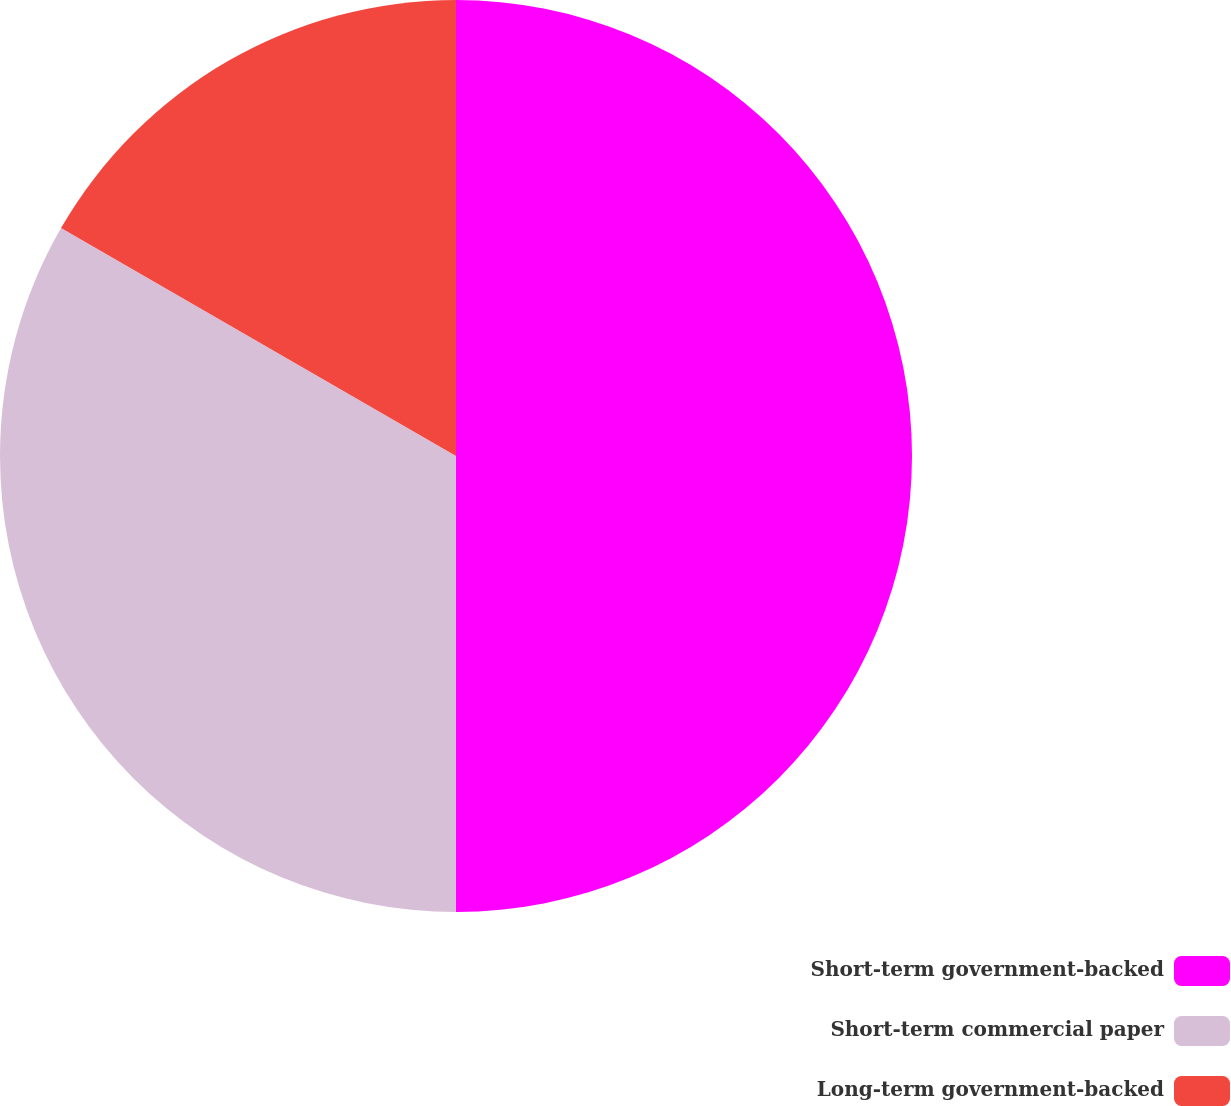<chart> <loc_0><loc_0><loc_500><loc_500><pie_chart><fcel>Short-term government-backed<fcel>Short-term commercial paper<fcel>Long-term government-backed<nl><fcel>50.0%<fcel>33.33%<fcel>16.67%<nl></chart> 